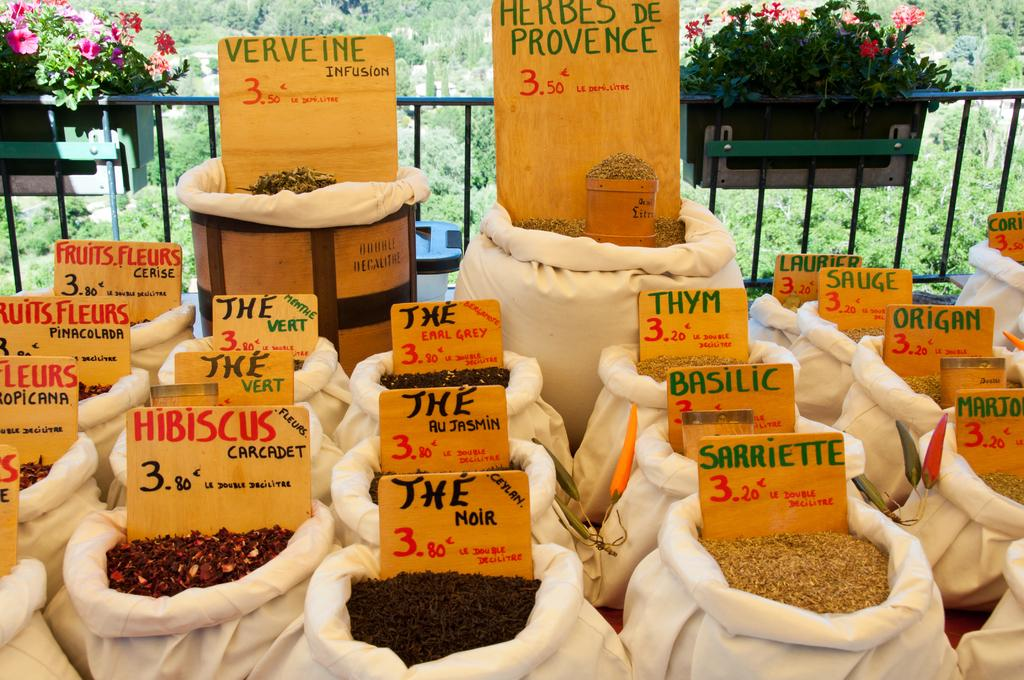What items are in bags with name boards in the image? There are seeds and herbs in bags with name boards in the image. What type of plants can be seen in the background of the image? There are plants with flowers in the background of the image. What architectural feature is visible in the background of the image? There are iron grills in the background of the image. What type of vegetation is visible in the background of the image? There are trees in the background of the image. What is visible in the sky in the background of the image? The sky is visible in the background of the image. How does the harmony between the plants and the iron grills contribute to the image? There is no mention of harmony between the plants and the iron grills in the image, as the facts provided do not discuss any relationship between these elements. 